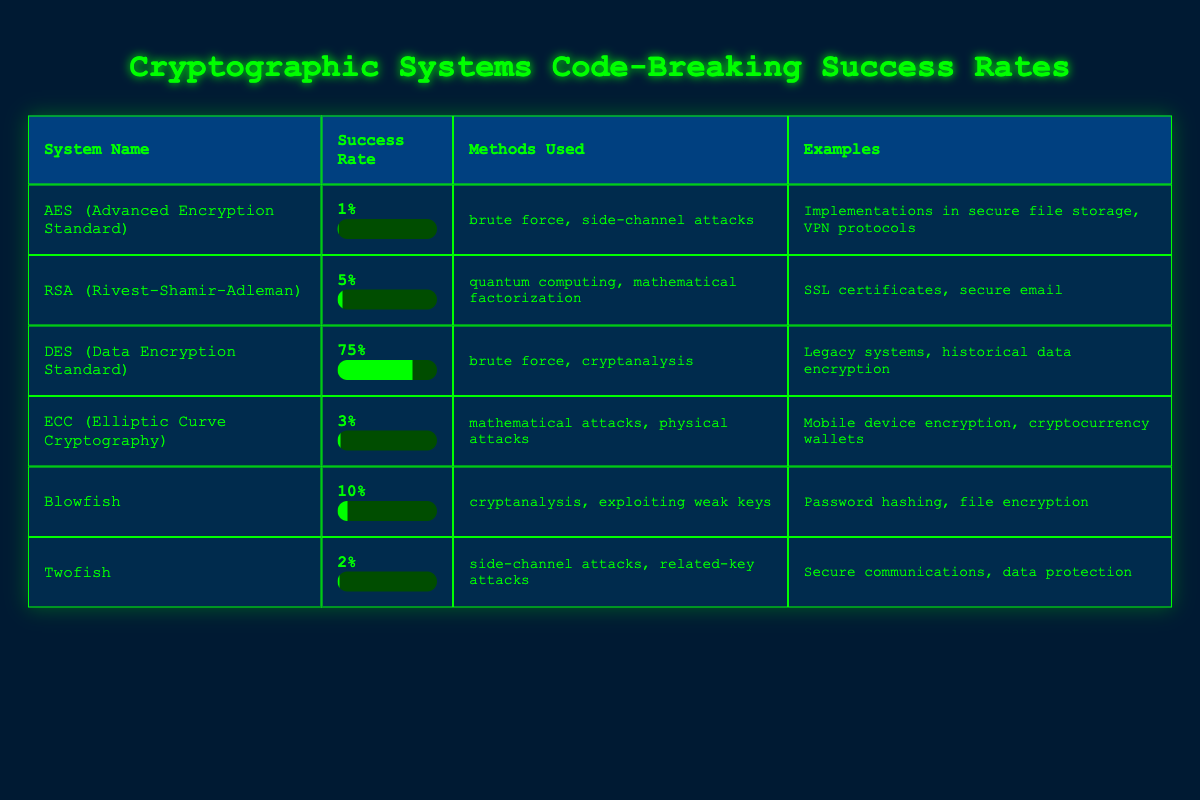What is the success rate of AES? The success rate for AES is listed directly in the table. It is shown as 1%.
Answer: 1% Which cryptographic system has the highest success rate? According to the table, DES has the highest success rate of 75%.
Answer: DES Is it true that Twofish has a higher success rate than ECC? By comparing the success rates in the table, Twofish has a success rate of 2% and ECC has a success rate of 3%. Since 2% is less than 3%, this statement is false.
Answer: No What are the methods used against RSA? The table lists the methods used against RSA as quantum computing and mathematical factorization.
Answer: Quantum computing and mathematical factorization If we sum the success rates of Blowfish and Twofish, what do we get? The success rate for Blowfish is 10% and for Twofish it is 2%. Summing these gives us 10 + 2 = 12.
Answer: 12 What is the difference in success rates between DES and AES? The success rate for DES is 75% and for AES it is 1%. The difference is calculated as 75 - 1 = 74.
Answer: 74 Which cryptographic system is primarily used in secure file storage? The examples column for AES indicates that it is used in secure file storage.
Answer: AES Out of the systems listed, which one has a success rate between 0% and 5%? Looking at the table, the systems that fall between 0% and 5% are AES with 1% and ECC with 3%.
Answer: AES and ECC Is Blowfish more vulnerable than RSA based on the success rates provided? Blowfish has a success rate of 10%, while RSA has a rate of 5%. Since 10% indicates a higher vulnerability, the statement is true.
Answer: Yes 